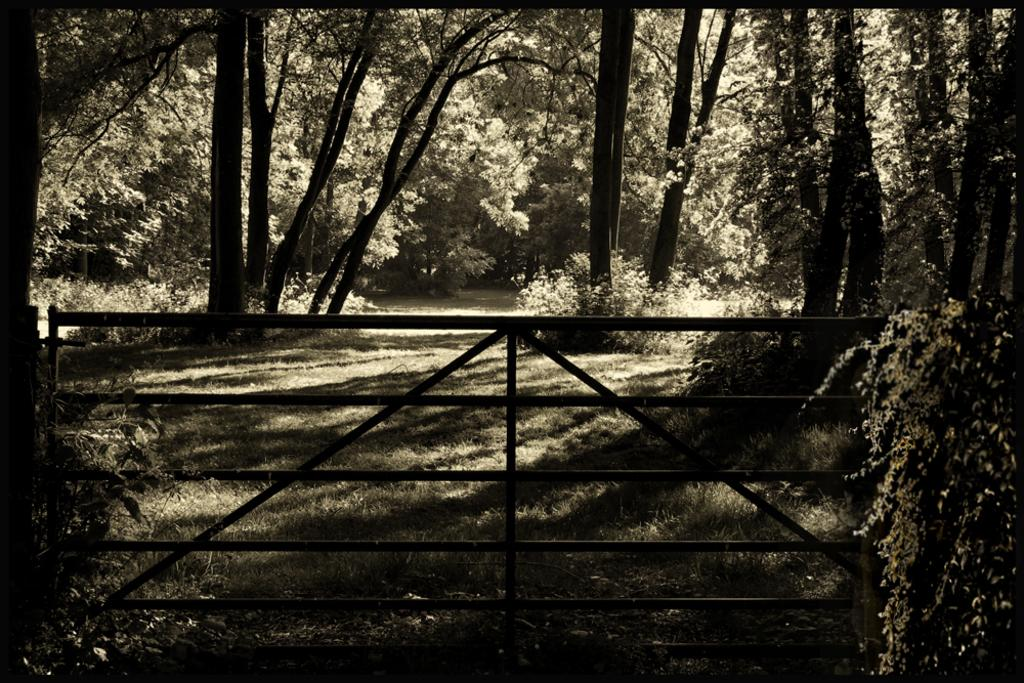What type of vegetation can be seen in the image? There are trees in the image. What type of structure is present in the image? There is an iron gate in the image. What word is written on the grape in the image? There is no grape present in the image, and therefore no word can be written on it. What type of fuel is being used by the trees in the image? Trees do not use fuel; they produce their own energy through photosynthesis. 